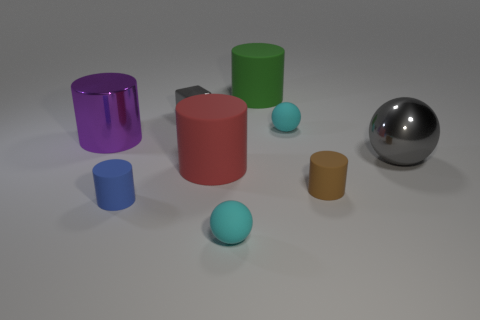Are there any other things of the same color as the tiny shiny cube?
Ensure brevity in your answer.  Yes. Is there a small gray metallic block that is on the left side of the cyan sphere left of the large matte object that is behind the purple metal object?
Offer a very short reply. Yes. Does the gray metallic thing that is behind the large gray object have the same shape as the blue matte thing?
Provide a succinct answer. No. Is the number of tiny brown matte cylinders that are in front of the big purple thing less than the number of tiny cyan matte objects that are right of the tiny gray metallic object?
Offer a terse response. Yes. What is the material of the large purple object?
Provide a succinct answer. Metal. Does the tiny block have the same color as the big shiny thing that is to the right of the big green thing?
Offer a terse response. Yes. How many gray metallic things are on the left side of the tiny blue matte thing?
Give a very brief answer. 0. Is the number of purple things that are behind the metallic sphere less than the number of big purple matte cubes?
Your answer should be compact. No. What color is the shiny cylinder?
Make the answer very short. Purple. Does the large cylinder left of the cube have the same color as the tiny metal thing?
Provide a succinct answer. No. 